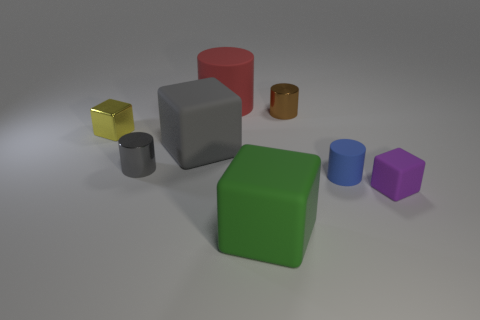Is the shape of the green rubber object the same as the yellow shiny thing that is behind the large gray matte block?
Offer a very short reply. Yes. There is a rubber object that is both to the left of the small purple matte cube and to the right of the green rubber cube; what color is it?
Ensure brevity in your answer.  Blue. Is there a tiny green metallic thing of the same shape as the red object?
Ensure brevity in your answer.  No. Are there any small blue things that are in front of the rubber cylinder on the left side of the green thing?
Give a very brief answer. Yes. How many objects are brown cylinders that are behind the large green thing or small cylinders that are right of the gray rubber block?
Keep it short and to the point. 2. What number of things are either small purple matte cylinders or tiny blocks that are to the left of the small gray metal cylinder?
Offer a very short reply. 1. There is a rubber cylinder that is behind the small shiny thing in front of the small block to the left of the big green object; what is its size?
Offer a terse response. Large. There is a gray cylinder that is the same size as the purple matte object; what is its material?
Provide a short and direct response. Metal. Is there a red thing of the same size as the blue cylinder?
Offer a very short reply. No. Does the matte object that is behind the brown shiny cylinder have the same size as the large gray cube?
Your answer should be very brief. Yes. 